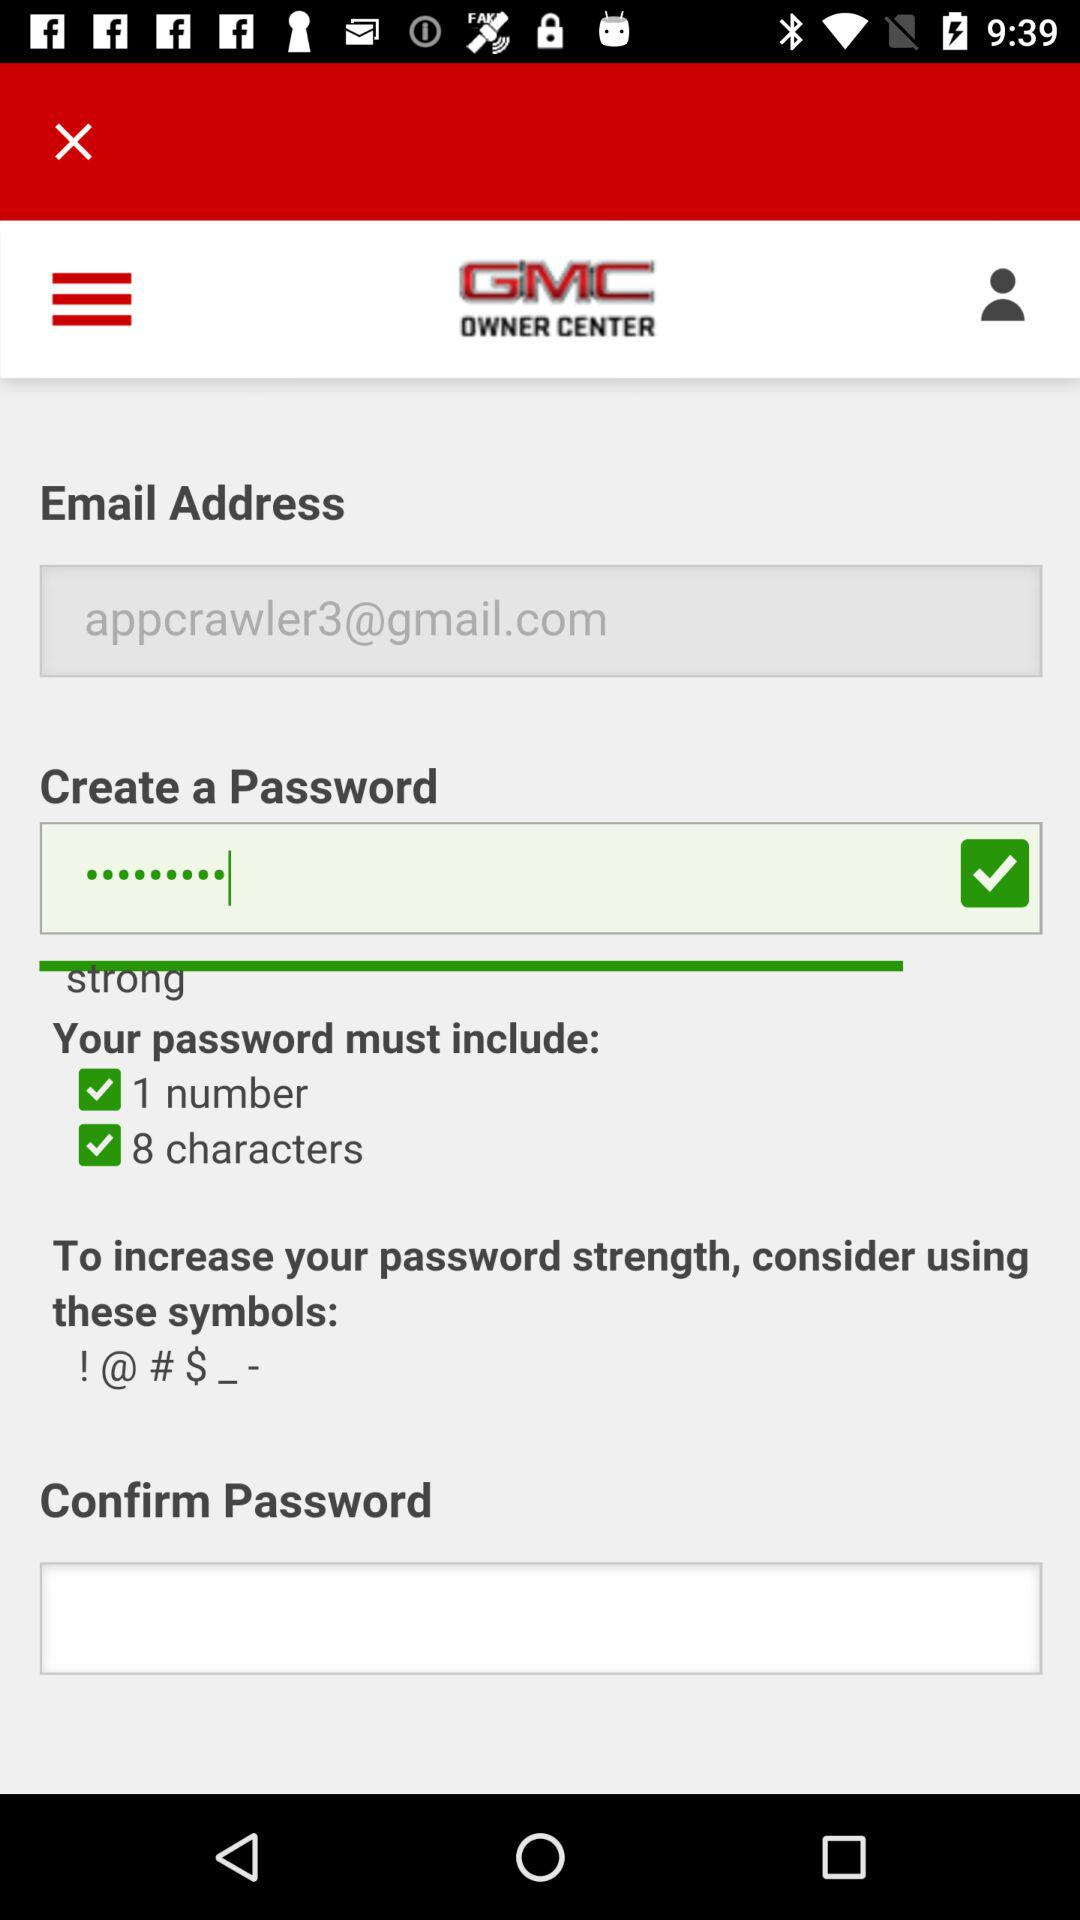How many numeric passwords must be included? The numeric password must include 1 number. 